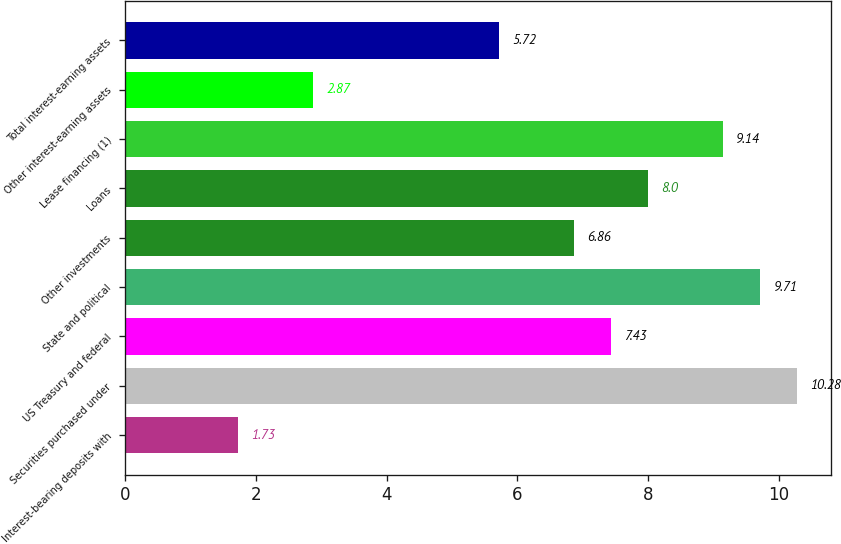Convert chart. <chart><loc_0><loc_0><loc_500><loc_500><bar_chart><fcel>Interest-bearing deposits with<fcel>Securities purchased under<fcel>US Treasury and federal<fcel>State and political<fcel>Other investments<fcel>Loans<fcel>Lease financing (1)<fcel>Other interest-earning assets<fcel>Total interest-earning assets<nl><fcel>1.73<fcel>10.28<fcel>7.43<fcel>9.71<fcel>6.86<fcel>8<fcel>9.14<fcel>2.87<fcel>5.72<nl></chart> 